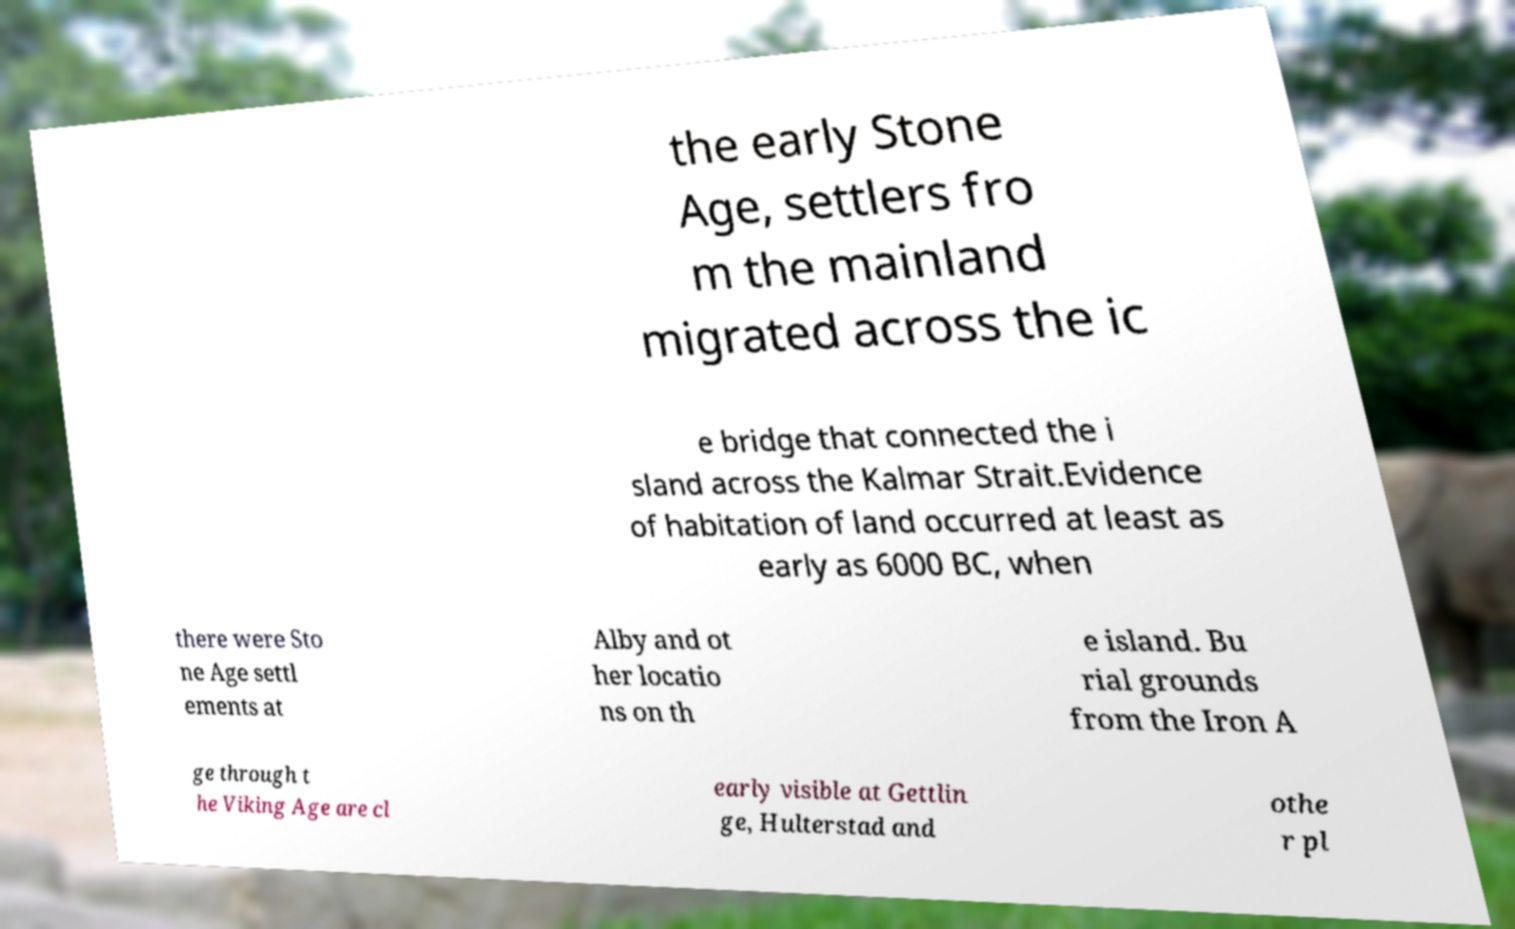Could you extract and type out the text from this image? the early Stone Age, settlers fro m the mainland migrated across the ic e bridge that connected the i sland across the Kalmar Strait.Evidence of habitation of land occurred at least as early as 6000 BC, when there were Sto ne Age settl ements at Alby and ot her locatio ns on th e island. Bu rial grounds from the Iron A ge through t he Viking Age are cl early visible at Gettlin ge, Hulterstad and othe r pl 